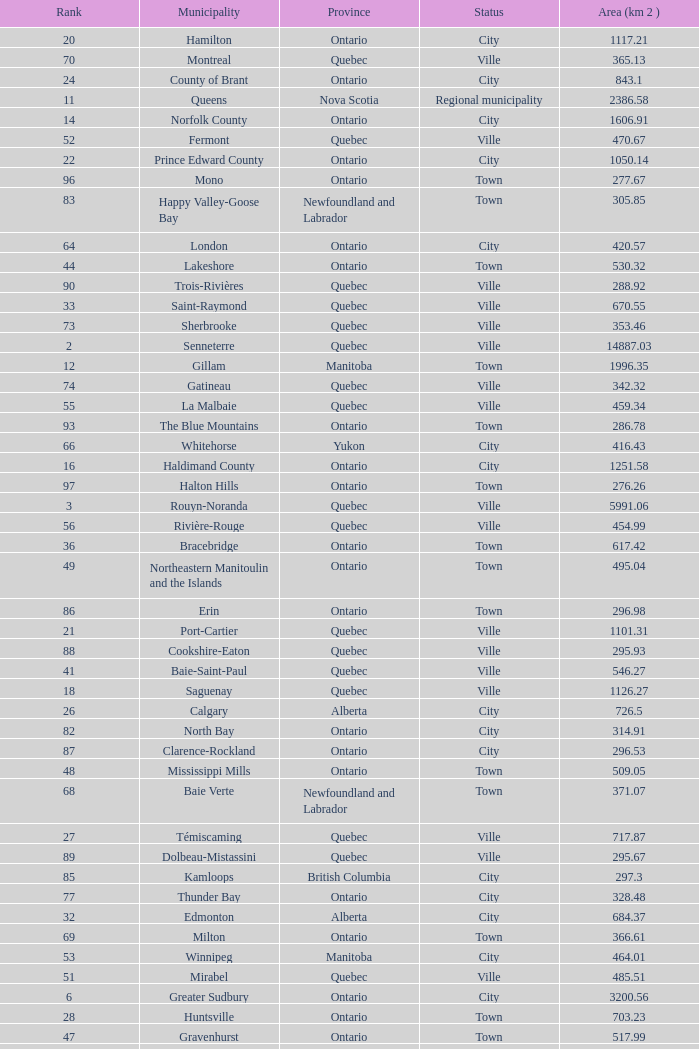What Municipality has a Rank of 44? Lakeshore. 